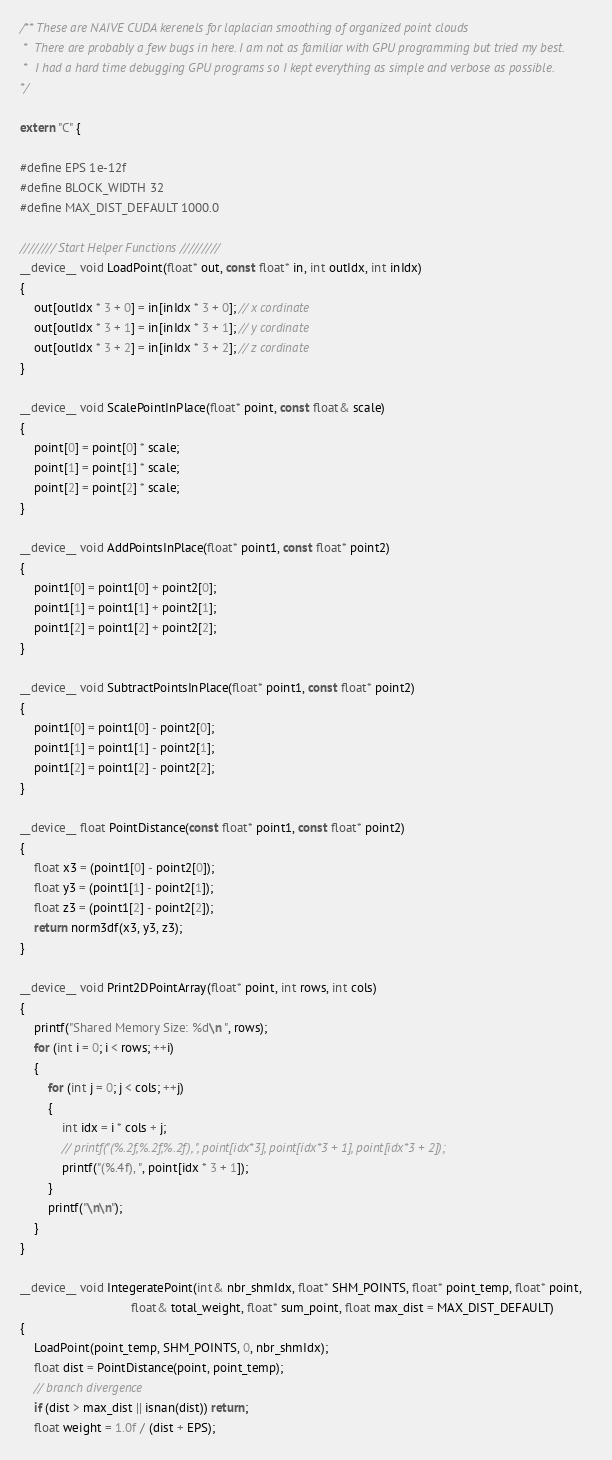<code> <loc_0><loc_0><loc_500><loc_500><_Cuda_>/** These are NAIVE CUDA kerenels for laplacian smoothing of organized point clouds
 *  There are probably a few bugs in here. I am not as familiar with GPU programming but tried my best.
 *  I had a hard time debugging GPU programs so I kept everything as simple and verbose as possible. 
*/

extern "C" {

#define EPS 1e-12f
#define BLOCK_WIDTH 32
#define MAX_DIST_DEFAULT 1000.0

//////// Start Helper Functions /////////
__device__ void LoadPoint(float* out, const float* in, int outIdx, int inIdx)
{
    out[outIdx * 3 + 0] = in[inIdx * 3 + 0]; // x cordinate
    out[outIdx * 3 + 1] = in[inIdx * 3 + 1]; // y cordinate
    out[outIdx * 3 + 2] = in[inIdx * 3 + 2]; // z cordinate
}

__device__ void ScalePointInPlace(float* point, const float& scale)
{
    point[0] = point[0] * scale;
    point[1] = point[1] * scale;
    point[2] = point[2] * scale;
}

__device__ void AddPointsInPlace(float* point1, const float* point2)
{
    point1[0] = point1[0] + point2[0];
    point1[1] = point1[1] + point2[1];
    point1[2] = point1[2] + point2[2];
}

__device__ void SubtractPointsInPlace(float* point1, const float* point2)
{
    point1[0] = point1[0] - point2[0];
    point1[1] = point1[1] - point2[1];
    point1[2] = point1[2] - point2[2];
}

__device__ float PointDistance(const float* point1, const float* point2)
{
    float x3 = (point1[0] - point2[0]);
    float y3 = (point1[1] - point2[1]);
    float z3 = (point1[2] - point2[2]);
    return norm3df(x3, y3, z3);
}

__device__ void Print2DPointArray(float* point, int rows, int cols)
{
    printf("Shared Memory Size: %d\n ", rows);
    for (int i = 0; i < rows; ++i)
    {
        for (int j = 0; j < cols; ++j)
        {
            int idx = i * cols + j;
            // printf("(%.2f,%.2f,%.2f), ", point[idx*3], point[idx*3 + 1], point[idx*3 + 2]);
            printf("(%.4f), ", point[idx * 3 + 1]);
        }
        printf("\n\n");
    }
}

__device__ void IntegeratePoint(int& nbr_shmIdx, float* SHM_POINTS, float* point_temp, float* point,
                                float& total_weight, float* sum_point, float max_dist = MAX_DIST_DEFAULT)
{
    LoadPoint(point_temp, SHM_POINTS, 0, nbr_shmIdx);
    float dist = PointDistance(point, point_temp);
    // branch divergence
    if (dist > max_dist || isnan(dist)) return;
    float weight = 1.0f / (dist + EPS);</code> 